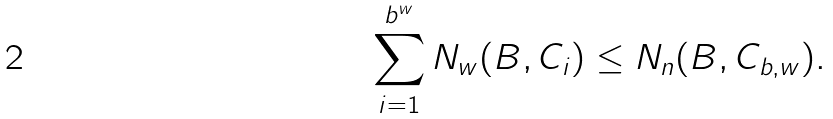<formula> <loc_0><loc_0><loc_500><loc_500>\sum _ { i = 1 } ^ { b ^ { w } } N _ { w } ( B , C _ { i } ) \leq N _ { n } ( B , C _ { b , w } ) .</formula> 